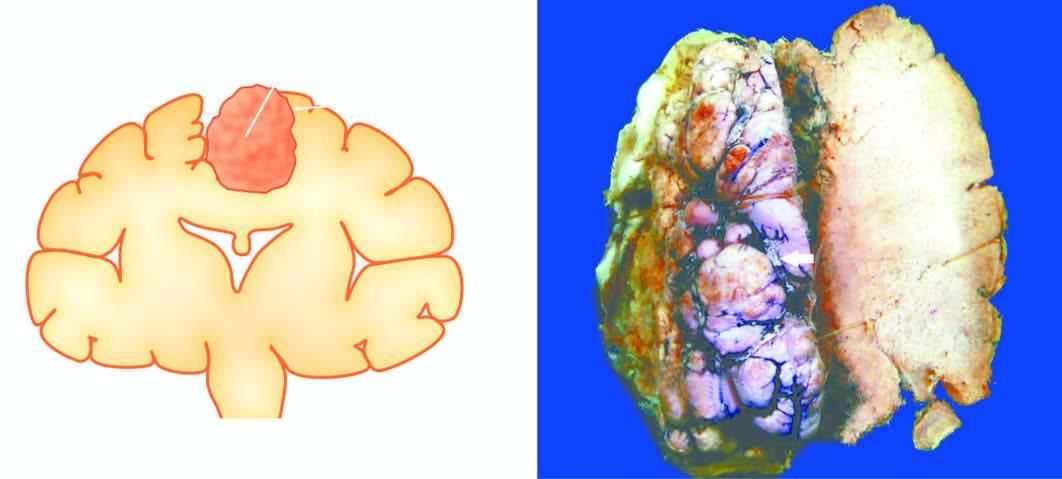s photomicrograph on right under higher magnification circumscribed with irregular surface convolutions and prominent blood vessels?
Answer the question using a single word or phrase. No 